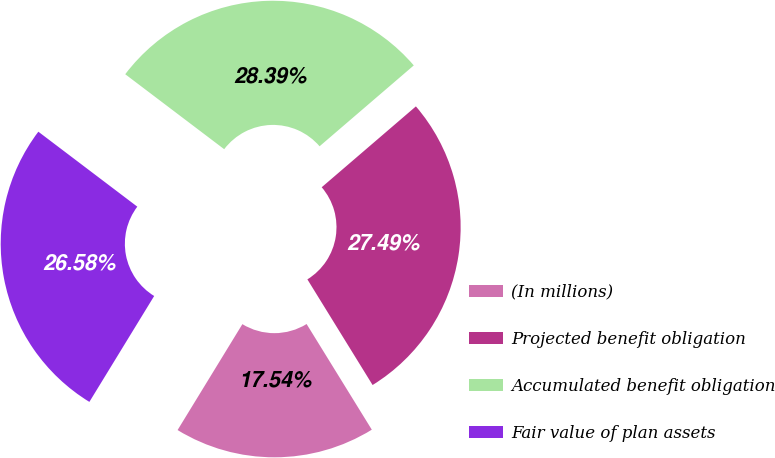Convert chart to OTSL. <chart><loc_0><loc_0><loc_500><loc_500><pie_chart><fcel>(In millions)<fcel>Projected benefit obligation<fcel>Accumulated benefit obligation<fcel>Fair value of plan assets<nl><fcel>17.54%<fcel>27.49%<fcel>28.39%<fcel>26.58%<nl></chart> 